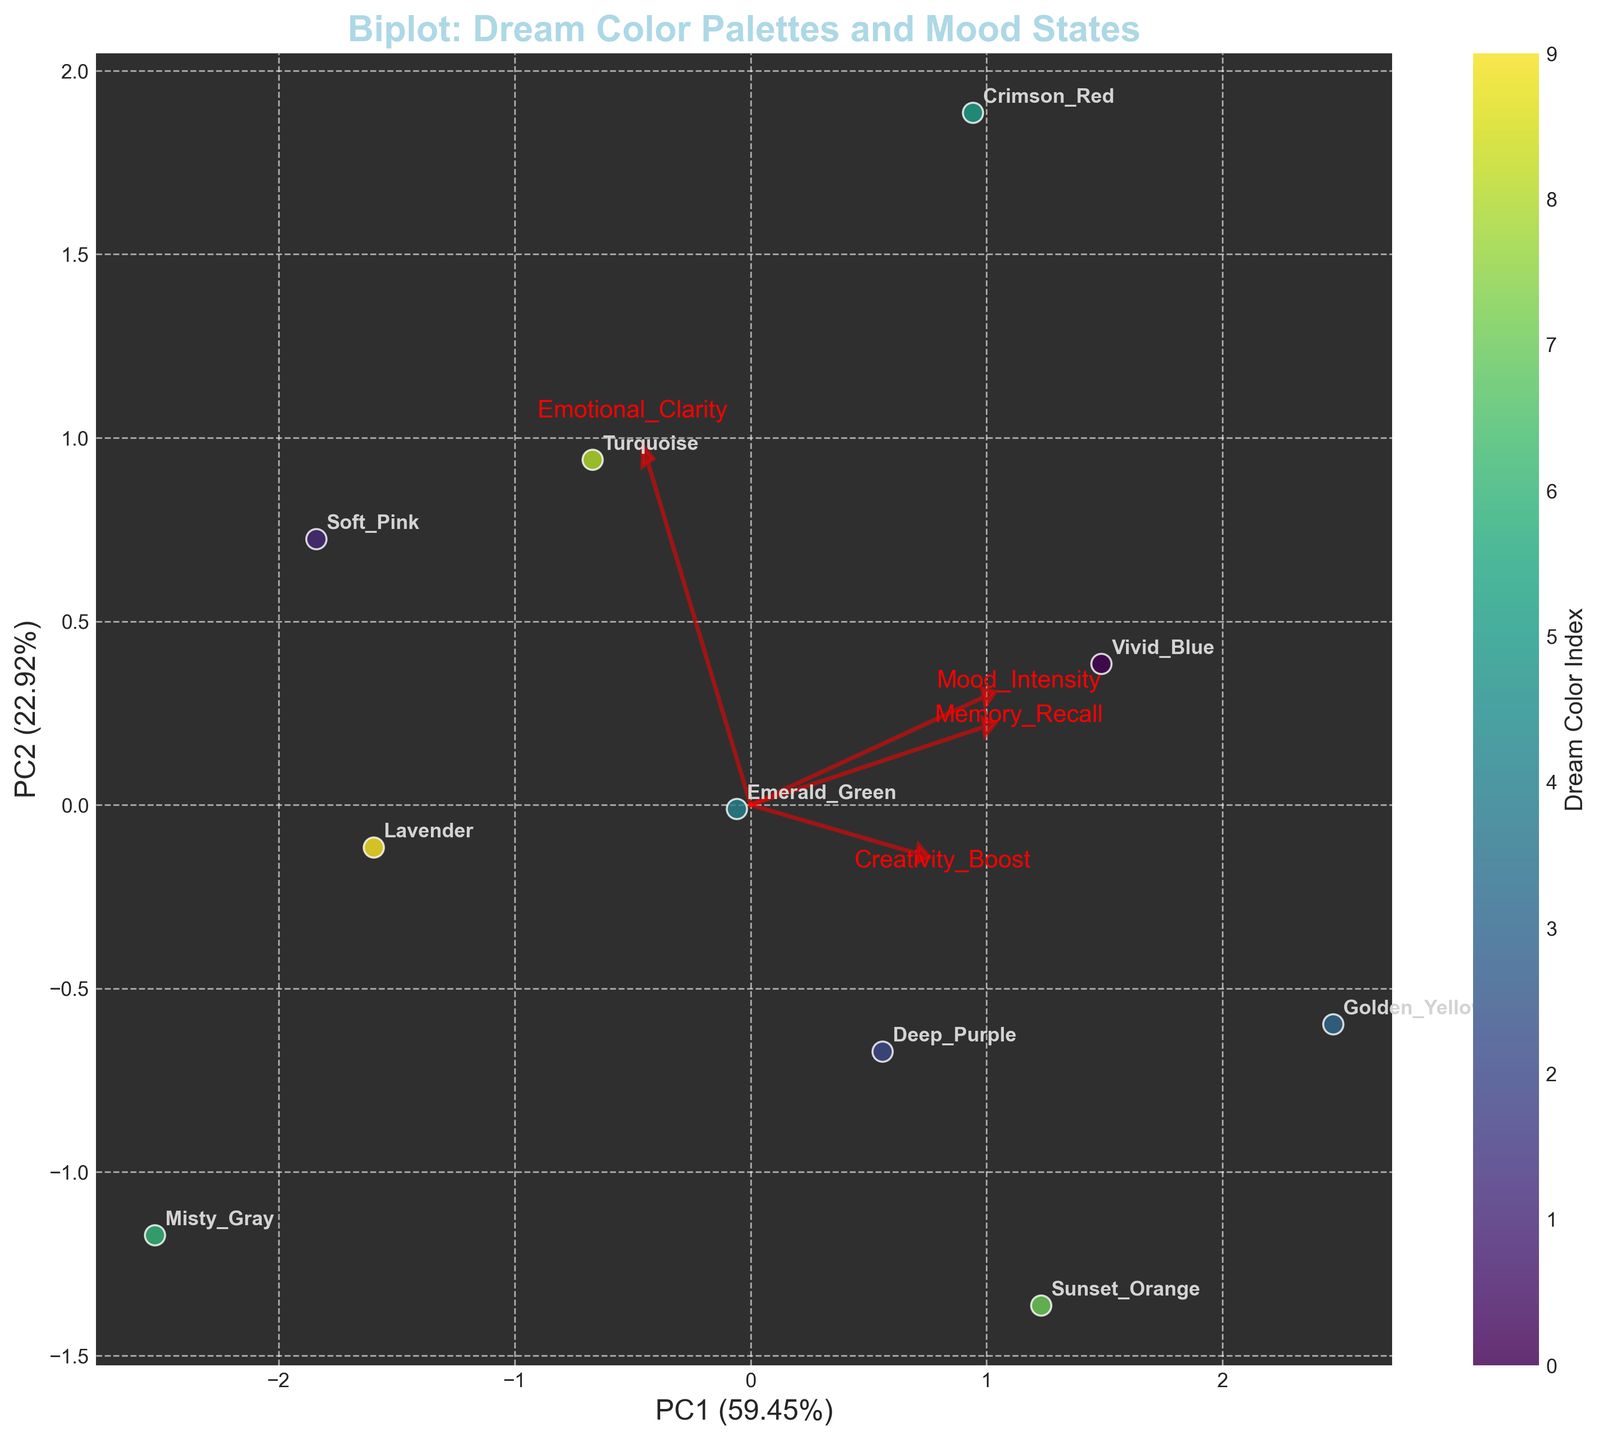What is the title of the chart? The title of the chart is presented at the top within its border and reads "Biplot: Dream Color Palettes and Mood States.”
Answer: Biplot: Dream Color Palettes and Mood States How many dream color points are displayed on the biplot? Each data point represents a dream color. By counting the highlighted points on the plot, we can see there are 10 data points.
Answer: 10 Which dream color has the highest Mood Intensity and where is it located on the plot? The dream color "Golden Yellow" has the highest Mood Intensity of 0.9 among all data points. Hence, its corresponding point should be positioned at the farthest extent along the loading vector for Mood Intensity.
Answer: Golden Yellow What percentage of information is captured by the first principal component (PC1)? To determine this, look at the x-axis label, which mentions the percentage of variance the first principal component explains. The label shows “PC1 (56.78%)” indicating that 56.78% of the information is captured by PC1.
Answer: 56.78% Which two dream colors have the closest placement on the plot? By visually inspecting the dream colors, "Soft Pink" and "Lavender" are situated nearly at the same spot on the biplot. They are closely aligned in terms of their coordinates and barely differ in their placement.
Answer: Soft Pink and Lavender How does Creativity Boost compare for "Vivid Blue" and “Misty Gray”? To compare these two values, trace their positions along the loading vector labeled Creativity Boost. "Vivid Blue" is positioned closer to the high end of the Creativity Boost vector than “Misty Gray,” indicating it has a higher Creativity Boost.
Answer: Vivid Blue has higher Creativity Boost than Misty Gray Which dream color is positioned farthest along the Principal Component 2 (PC2) axis? The dream colors are scattered across both axes. Observing the vertical spread of the points indicates that "Soft Pink" is farthest along the PC2 axis on the positive side.
Answer: Soft Pink What can be said about mood intensity correlation with creativity boost based on the loadings’ vectors? By examining the angles and directions of the loading vectors for Mood Intensity and Creativity Boost, we observe that they are nearly parallel and both extend outward, signifying a positive correlation between these two variables.
Answer: Positive correlation Which dream color exhibits the highest combination of Emotional Clarity and Memory Recall? By viewing the loadings, find clues where combined high values appear. "Golden Yellow" aligns closely with the vectors of Emotional Clarity and Memory Recall. Observing this close linkage signifies "Golden Yellow" posits the highest conjoined values.
Answer: Golden Yellow Can you identify any dream color that might diminish both Memory Recall and Emotional Clarity? Which one? Locate which colors fall negatively along the Emotional Clarity and Memory Recall vectors. "Misty Gray" is unique to both loading directions, indicating it likely diminishes these qualities.
Answer: Misty Gray 